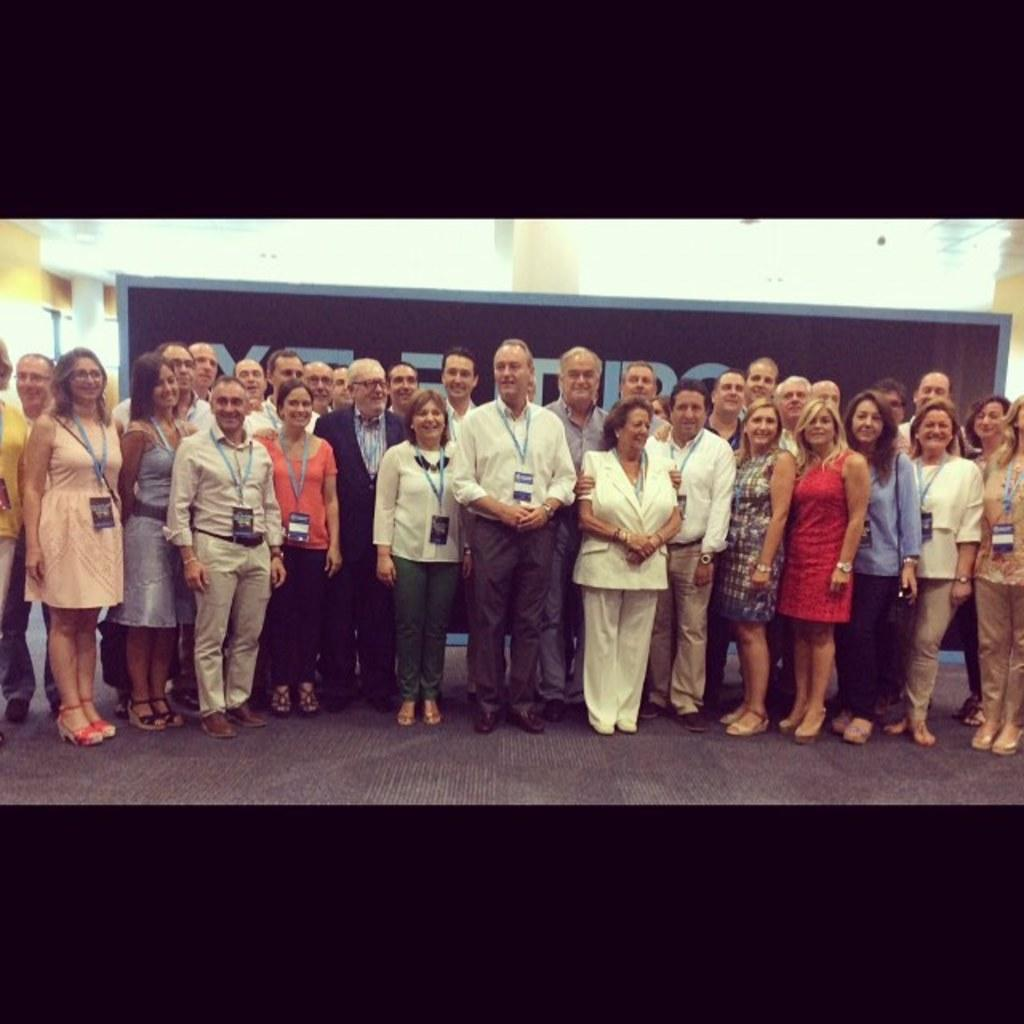How many people are in the group shown in the image? There is a group of people in the image, but the exact number cannot be determined from the provided facts. What are some people in the group wearing? Some people in the group are wearing identity cards. What can be seen on the board in the image? There is a board with text in the image. Can you describe the frog sitting on the board in the image? There is no frog present in the image; it only features a group of people and a board with text. 